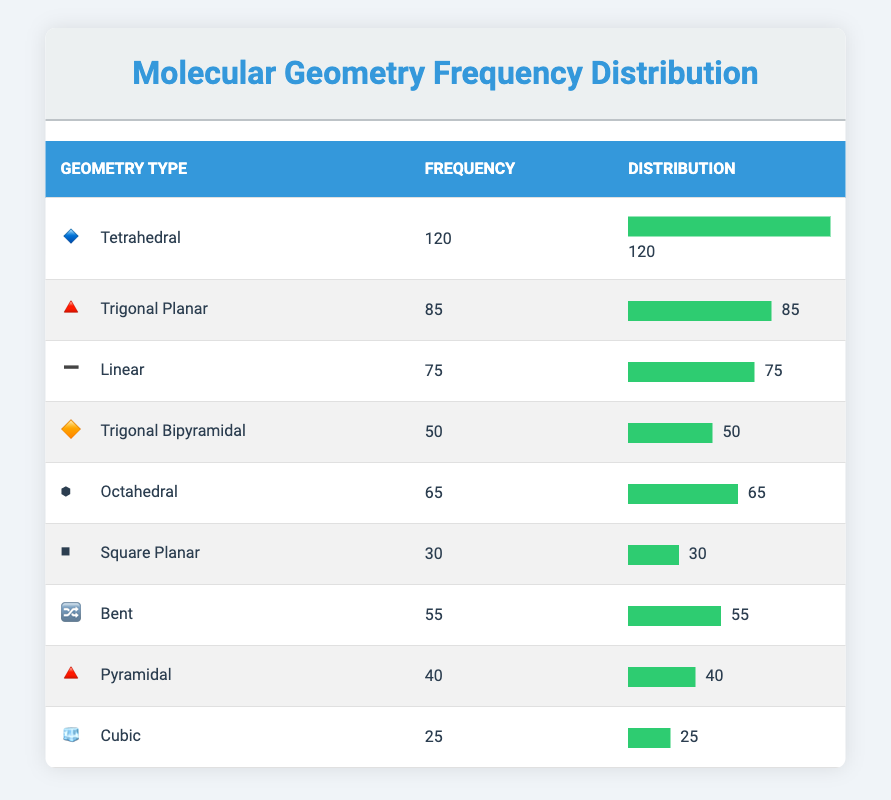What is the maximum frequency of molecular geometry reported in the table? The table lists different geometry types along with their frequencies. The maximum frequency is the highest value in the frequency column, which is 120 for the Tetrahedral geometry.
Answer: 120 Which molecular geometry has the lowest frequency? By examining the frequency column in the table, the lowest frequency value is 25, which corresponds to the Cubic geometry type.
Answer: 25 How many geometries have a frequency greater than 50? From the frequency column, we find the geometries with frequencies greater than 50: Tetrahedral (120), Trigonal Planar (85), Linear (75), Octahedral (65), and Bent (55). There are a total of 5 geometries fitting this criterion.
Answer: 5 What is the average frequency of the geometries listed in the table? To calculate the average frequency, we sum all the frequency values: 120 + 85 + 75 + 50 + 65 + 30 + 55 + 40 + 25 = 545. Then, we divide this sum by the number of geometries, which is 9. So, 545 / 9 = approximately 60.56.
Answer: 60.56 Is the frequency of Pyramidal greater than that of Square Planar? The frequency for Pyramidal is 40, and for Square Planar, it is 30. Since 40 is greater than 30, the statement is true.
Answer: Yes What is the total frequency of geometries that are classified as planar (Trigonal Planar and Square Planar)? The frequencies for Trigonal Planar (85) and Square Planar (30) are added together: 85 + 30 = 115. This sums up to a total frequency of 115 for the planar geometries.
Answer: 115 How many geometries have a frequency between 30 and 70? We check the frequencies of the geometries: Square Planar (30), Pyramidal (40), Bent (55), and Octahedral (65) all fall within the range of 30 to 70. That makes for a total of 4 geometries.
Answer: 4 What is the difference in frequency between Tetrahedral and Trigonal Bipyramidal geometries? The frequency of Tetrahedral is 120, and for Trigonal Bipyramidal, it is 50. The difference is calculated as 120 - 50 = 70, indicating a significant variation in their occurrences.
Answer: 70 